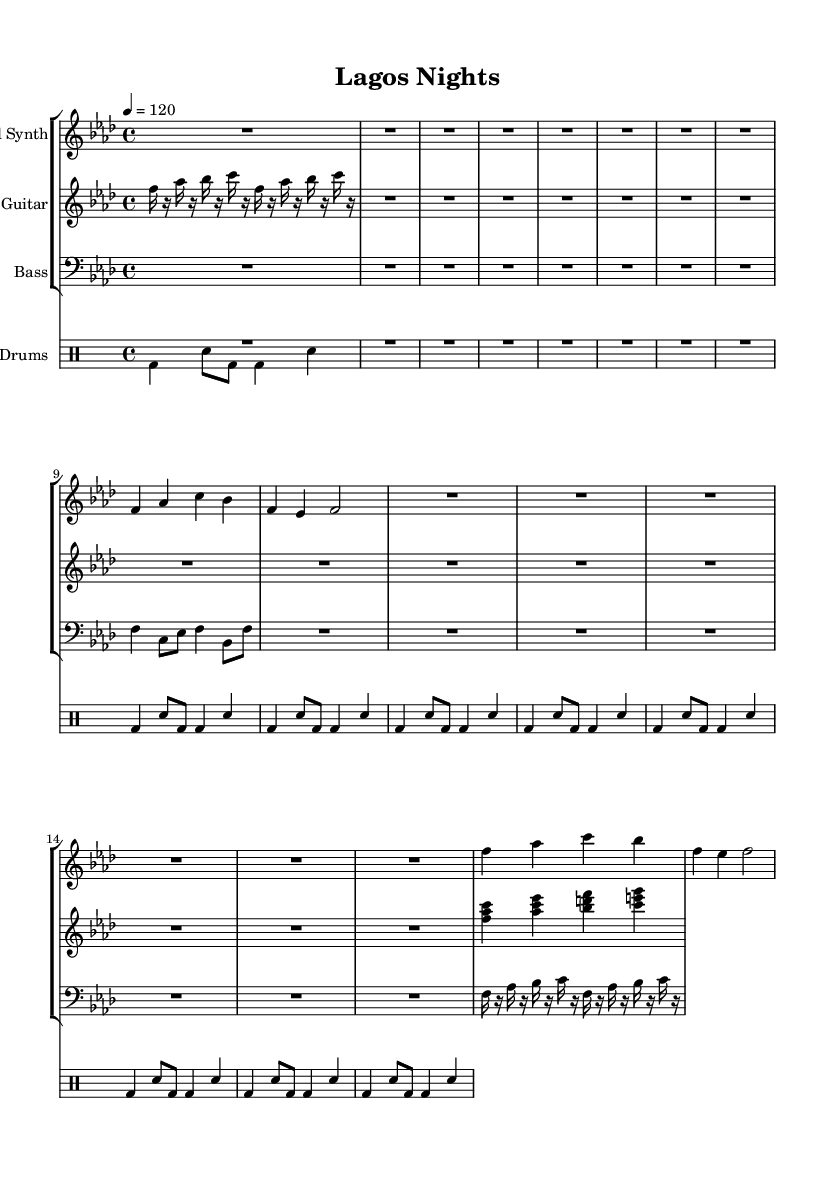What is the key signature of this music? The key signature is indicated at the beginning of the staff. There are four flats in the key signature, which corresponds to F minor.
Answer: F minor What is the time signature of this piece? The time signature is noted right after the key signature. It shows a 4 on top of a 4, indicating that there are four beats in each measure.
Answer: 4/4 What is the tempo marking for this piece? The tempo is given in beats per minute (BPM) in the score. It reads "4 = 120", indicating the tempo should be 120 beats per minute.
Answer: 120 How many measures are indicated for the Lead Synth section? To find the number of measures, we count the vertical bar lines in the Lead Synth's part. There are eight measures in total.
Answer: 8 What instruments are present in the score? The instruments are listed by their respective groups. In the first group, there are "Lead Synth," "E. Guitar," and "Bass," while the second group features "Drums."
Answer: Lead Synth, E. Guitar, Bass, Drums What rhythmic pattern do the drums follow? The drum section shows a specific pattern that can be recognized by the repeated notes and rests in the drummode notation. The pattern indicated consists of bass drums and snare hits repeating every eight counts.
Answer: Bass-drum and snare pattern What unique characteristics define the Afrobeat style in this track? Afrobeat is characterized by complex polyrhythms, often layering multiple rhythmic patterns on top of each other, along with contemporary production elements. In this score, the interlocking rhythms of the drums and syncopation in the synth parts exemplify this style.
Answer: Polyrhythms and contemporary production 